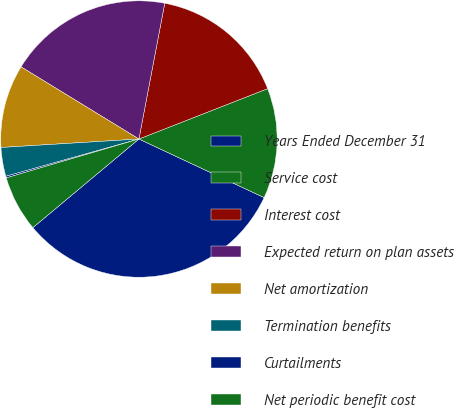<chart> <loc_0><loc_0><loc_500><loc_500><pie_chart><fcel>Years Ended December 31<fcel>Service cost<fcel>Interest cost<fcel>Expected return on plan assets<fcel>Net amortization<fcel>Termination benefits<fcel>Curtailments<fcel>Net periodic benefit cost<nl><fcel>31.96%<fcel>12.9%<fcel>16.07%<fcel>19.25%<fcel>9.72%<fcel>3.37%<fcel>0.19%<fcel>6.54%<nl></chart> 